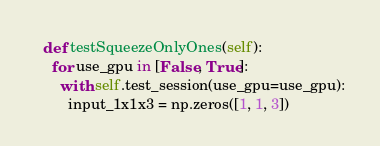<code> <loc_0><loc_0><loc_500><loc_500><_Python_>  def testSqueezeOnlyOnes(self):
    for use_gpu in [False, True]:
      with self.test_session(use_gpu=use_gpu):
        input_1x1x3 = np.zeros([1, 1, 3])</code> 